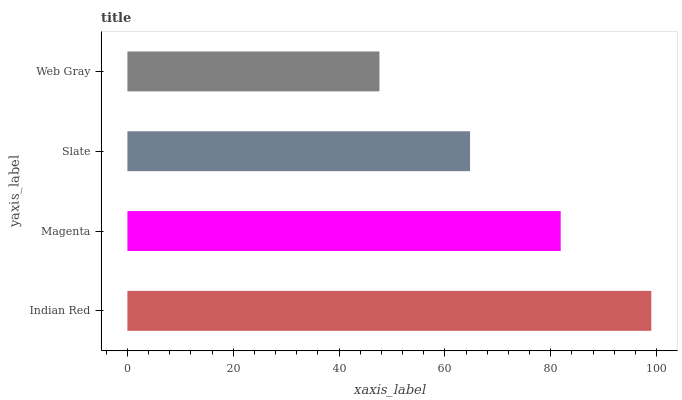Is Web Gray the minimum?
Answer yes or no. Yes. Is Indian Red the maximum?
Answer yes or no. Yes. Is Magenta the minimum?
Answer yes or no. No. Is Magenta the maximum?
Answer yes or no. No. Is Indian Red greater than Magenta?
Answer yes or no. Yes. Is Magenta less than Indian Red?
Answer yes or no. Yes. Is Magenta greater than Indian Red?
Answer yes or no. No. Is Indian Red less than Magenta?
Answer yes or no. No. Is Magenta the high median?
Answer yes or no. Yes. Is Slate the low median?
Answer yes or no. Yes. Is Slate the high median?
Answer yes or no. No. Is Indian Red the low median?
Answer yes or no. No. 